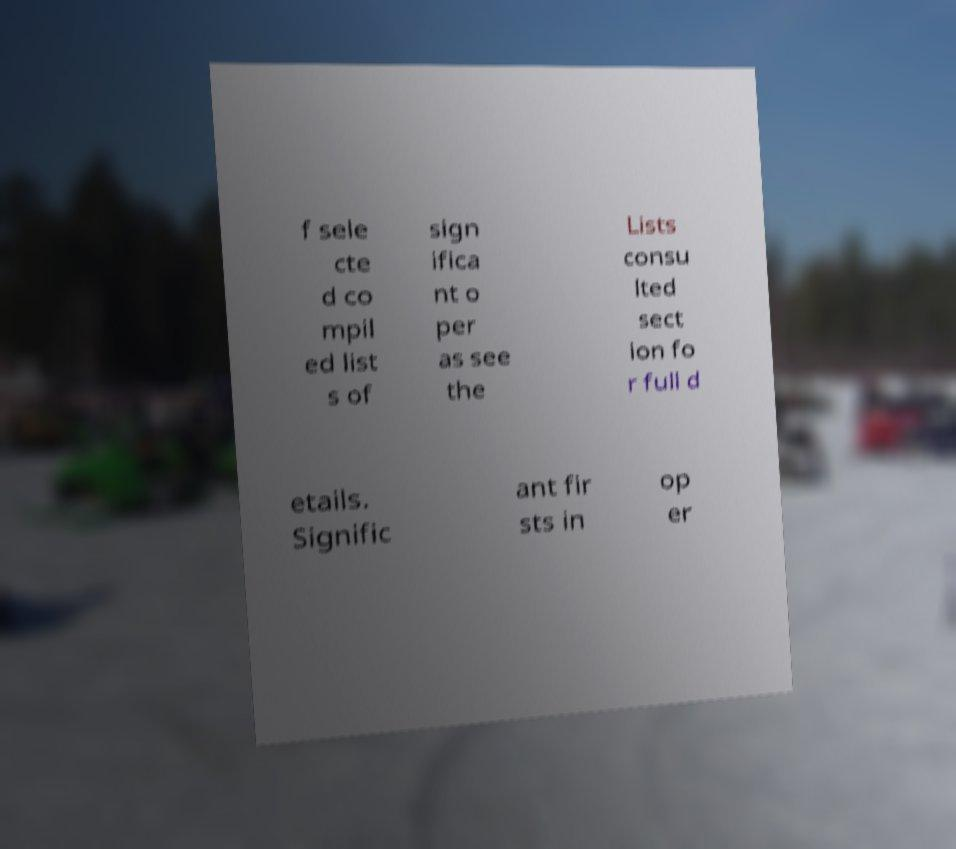What messages or text are displayed in this image? I need them in a readable, typed format. f sele cte d co mpil ed list s of sign ifica nt o per as see the Lists consu lted sect ion fo r full d etails. Signific ant fir sts in op er 